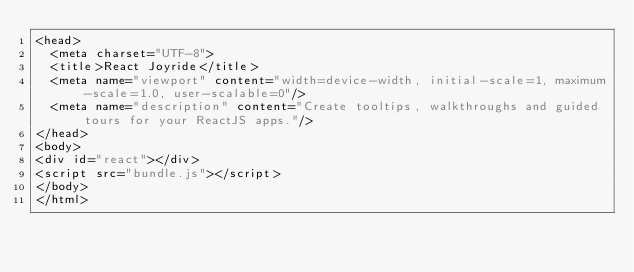Convert code to text. <code><loc_0><loc_0><loc_500><loc_500><_HTML_><head>
  <meta charset="UTF-8">
  <title>React Joyride</title>
  <meta name="viewport" content="width=device-width, initial-scale=1, maximum-scale=1.0, user-scalable=0"/>
  <meta name="description" content="Create tooltips, walkthroughs and guided tours for your ReactJS apps."/>
</head>
<body>
<div id="react"></div>
<script src="bundle.js"></script>
</body>
</html>
</code> 